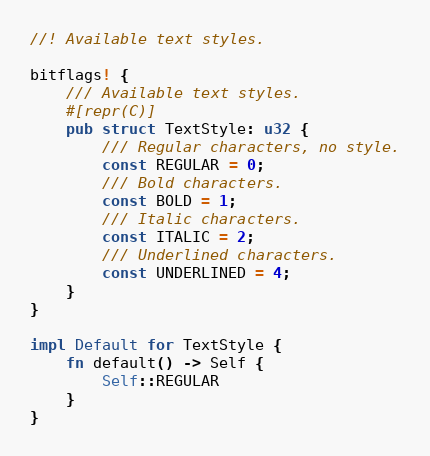<code> <loc_0><loc_0><loc_500><loc_500><_Rust_>//! Available text styles.

bitflags! {
    /// Available text styles.
    #[repr(C)]
    pub struct TextStyle: u32 {
        /// Regular characters, no style.
        const REGULAR = 0;
        /// Bold characters.
        const BOLD = 1;
        /// Italic characters.
        const ITALIC = 2;
        /// Underlined characters.
        const UNDERLINED = 4;
    }
}

impl Default for TextStyle {
    fn default() -> Self {
        Self::REGULAR
    }
}
</code> 